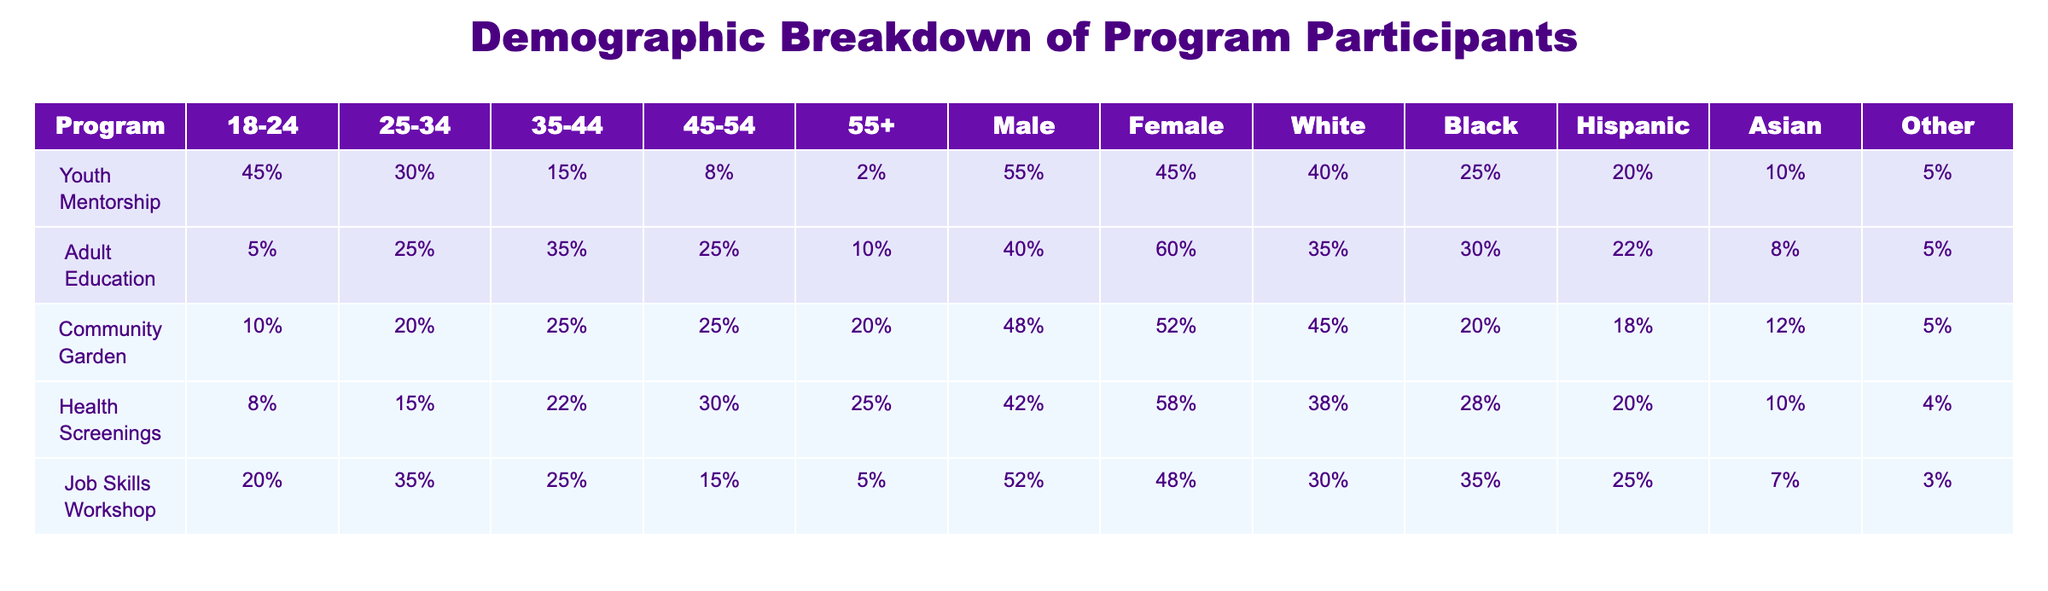What percentage of participants in the Youth Mentorship program are in the age group 18-24? The Youth Mentorship program shows that 45% of its participants are in the 18-24 age group, which is directly listed in the table under the corresponding column.
Answer: 45% In the Adult Education program, how many participants are female? The table indicates that in the Adult Education program, 60% of participants are female, as seen in the corresponding column for that program.
Answer: 60% Which program has the highest percentage of male participants? To find the program with the highest percentage of male participants, we compare the male percentages across all programs. The Job Skills Workshop has 52%, which is higher than other programs listed.
Answer: Job Skills Workshop What is the total percentage of participants aged 35-44 across all programs? Adding the percentages for the 35-44 age group from each program gives 15% (Youth Mentorship) + 35% (Adult Education) + 25% (Community Garden) + 22% (Health Screenings) + 25% (Job Skills Workshop) = 122%.
Answer: 122% Is there a program where participants aged 55 and older make up more than 10% of the population? Referring to the table, the Community Garden program has 20% of participants aged 55+, and the Health Screenings program has 25%. Therefore, both programs meet the condition stated in the question.
Answer: Yes What is the difference in percentage of Hispanic participants between the Health Screenings and the Job Skills Workshop programs? The percentage of Hispanic participants in Health Screenings is 20%, while in Job Skills Workshop, it is 25%. The difference is calculated as 25% - 20% = 5%.
Answer: 5% Which demographic group is most represented (in terms of percentages) in the Community Garden program? In the Community Garden program, while all demographic groups can be checked, Female participants make up 52% of the population, which is higher than any other group listed in that program.
Answer: Female Calculate the average age range representation of participants in the Job Skills Workshop program. The age percentages for the Job Skills Workshop are 20% (18-24), 35% (25-34), 25% (35-44), 15% (45-54), and 5% (55+). The average is calculated as (20% + 35% + 25% + 15% + 5%) / 5 = 20%.
Answer: 20% 